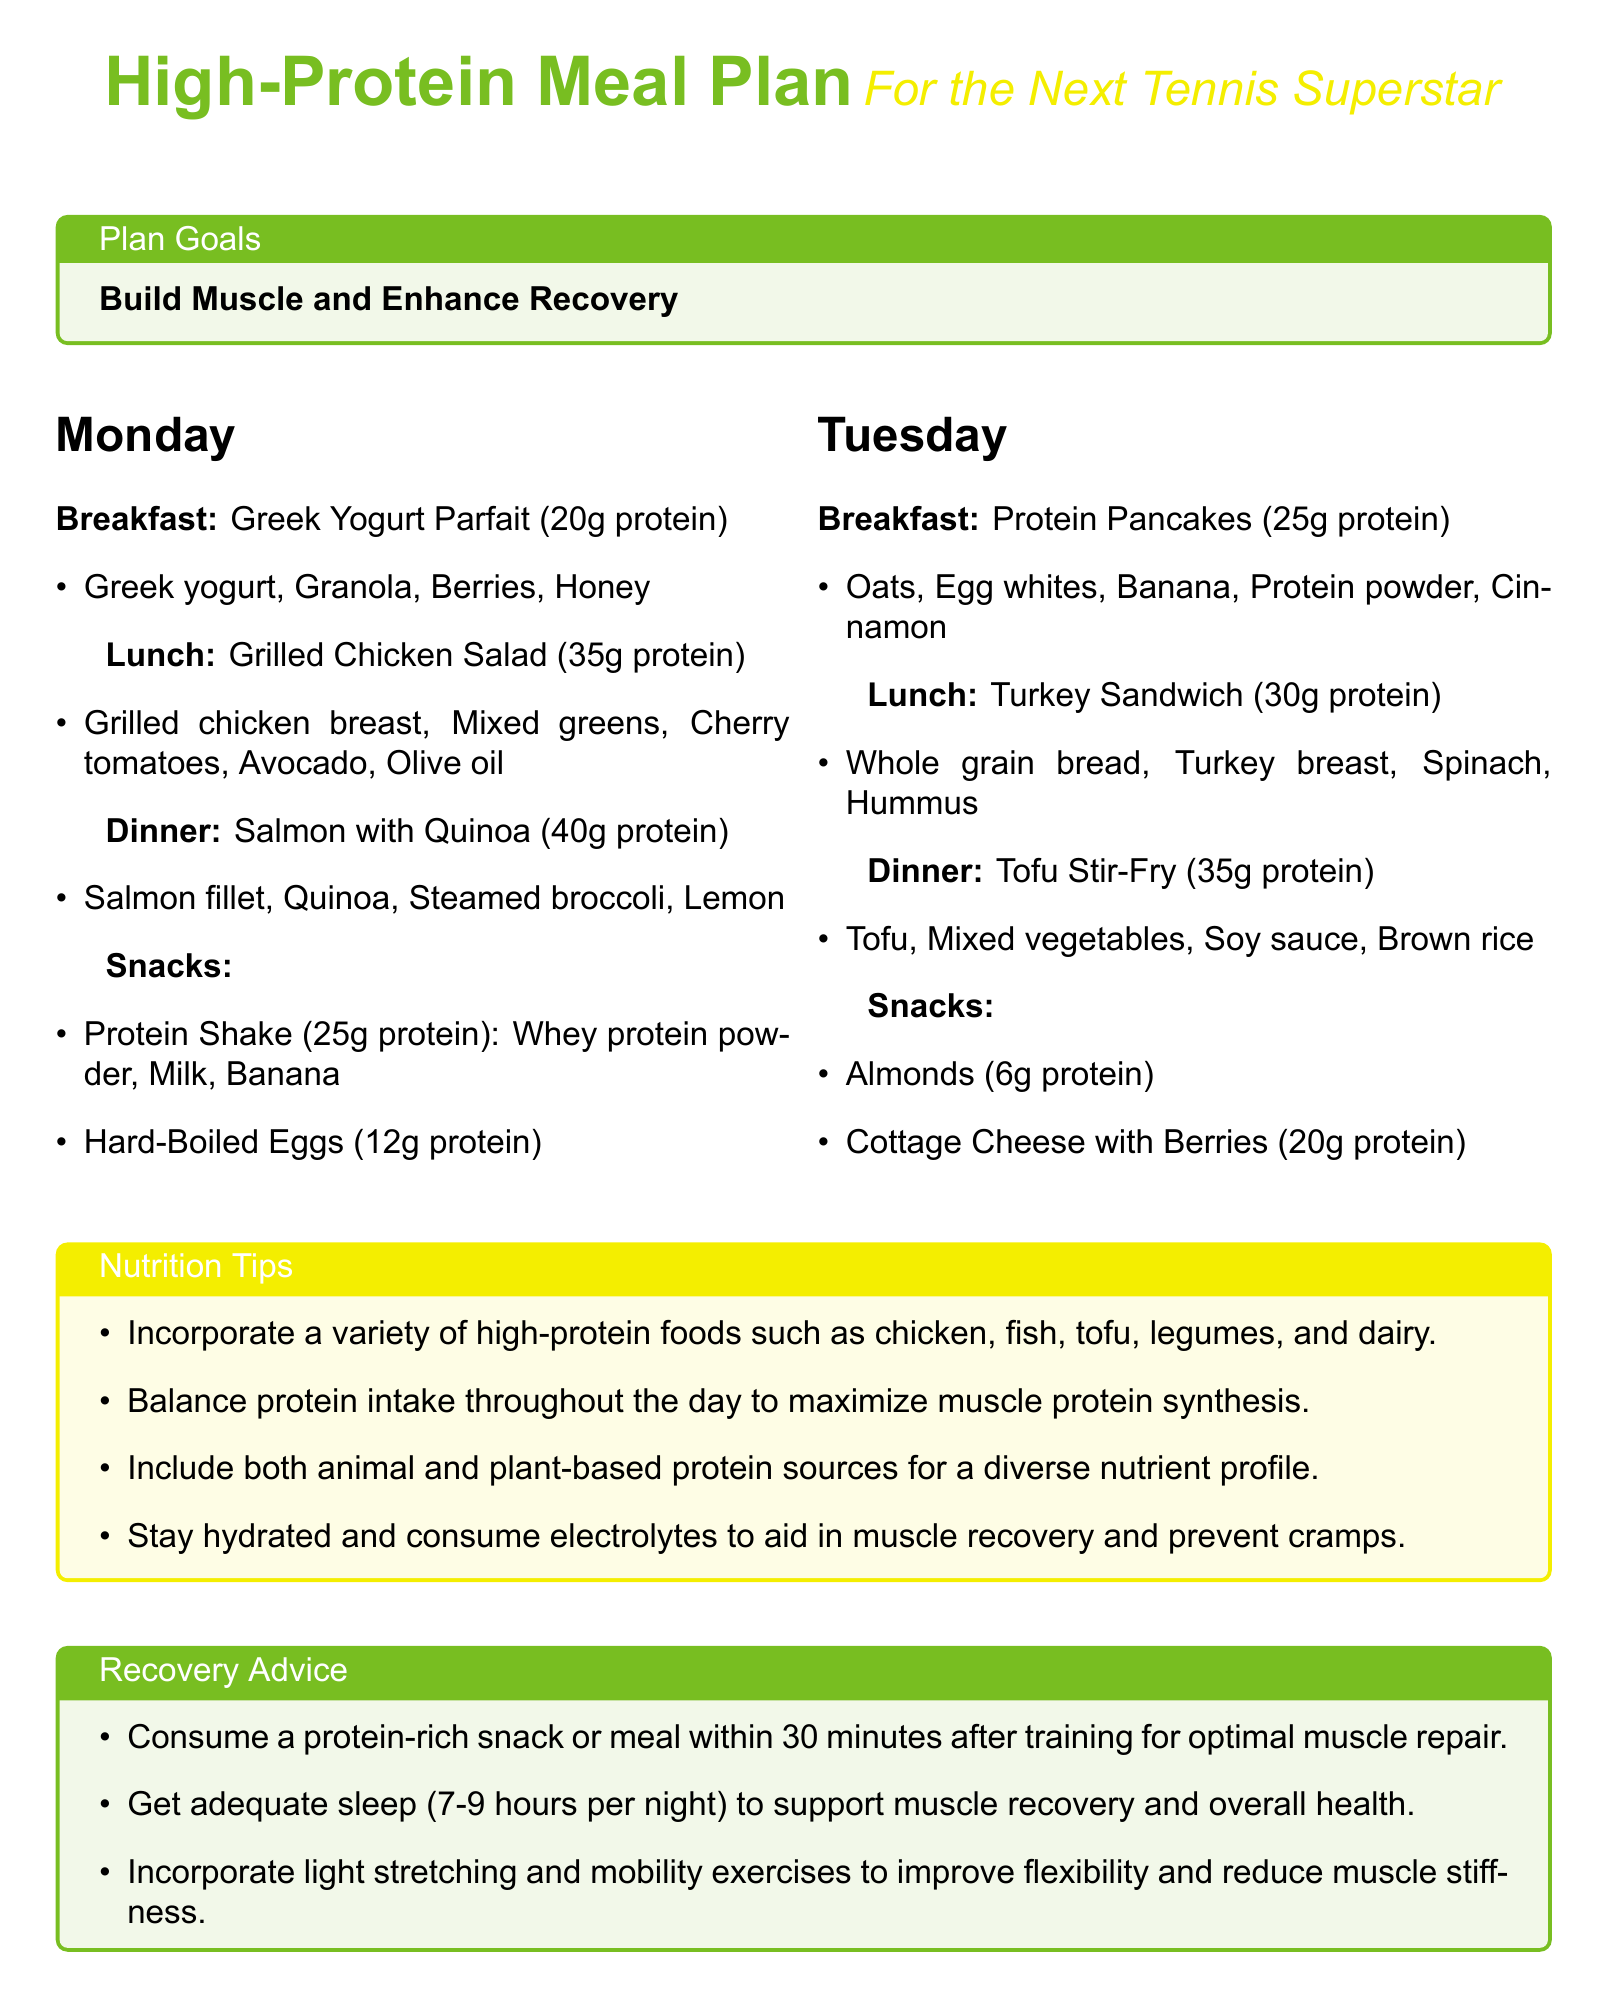What is the protein content of the Greek Yogurt Parfait? The Greek Yogurt Parfait contains 20g protein according to the meal plan.
Answer: 20g protein What is included in the Tofu Stir-Fry for dinner on Tuesday? Tofu Stir-Fry includes Tofu, Mixed vegetables, Soy sauce, and Brown rice as stated in the document.
Answer: Tofu, Mixed vegetables, Soy sauce, Brown rice How many grams of protein are in the Protein Pancakes? The Protein Pancakes are noted to contain 25g protein in the meal breakdown.
Answer: 25g protein What is a recommended protein source for snacks? The meal plan suggests Hard-Boiled Eggs as a snack option, containing 12g protein.
Answer: Hard-Boiled Eggs Which day features a Grilled Chicken Salad? The Grilled Chicken Salad is listed for Monday in the meal plan.
Answer: Monday What should you consume within 30 minutes after training? The recovery advice states to consume a protein-rich snack or meal within 30 minutes after training.
Answer: protein-rich snack or meal How many hours of sleep are recommended for muscle recovery? The document advises getting 7-9 hours of sleep per night to support muscle recovery.
Answer: 7-9 hours Which color represents the Nutrition Tips section? The Nutrition Tips section is highlighted in tennis yellow as described in the plan.
Answer: tennis yellow What is the primary goal of this meal plan? The plan states that the primary goal is to build muscle and enhance recovery.
Answer: Build Muscle and Enhance Recovery 